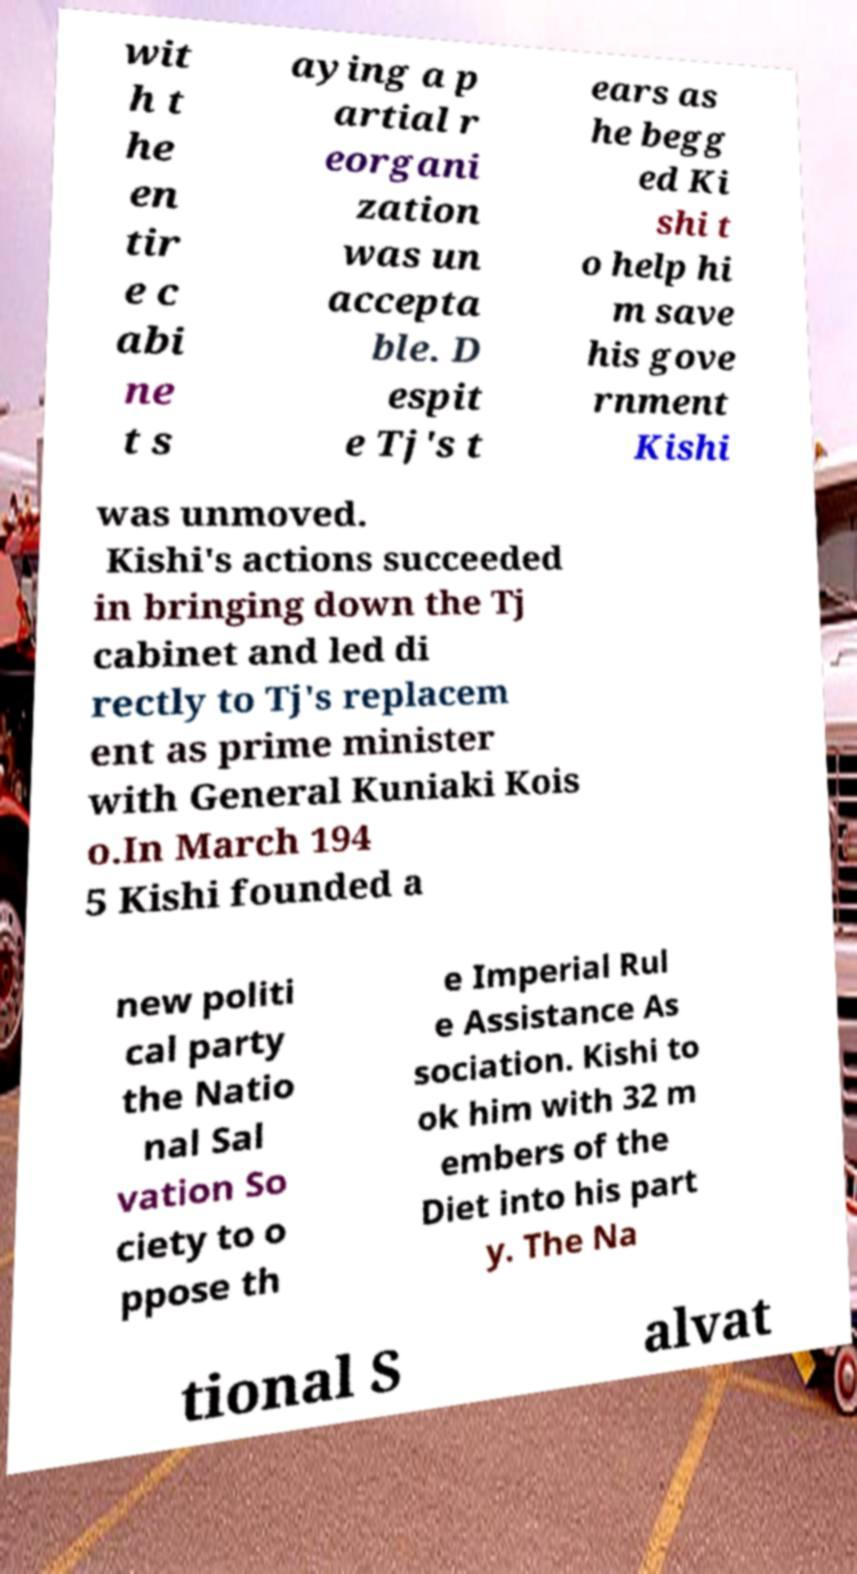Could you extract and type out the text from this image? wit h t he en tir e c abi ne t s aying a p artial r eorgani zation was un accepta ble. D espit e Tj's t ears as he begg ed Ki shi t o help hi m save his gove rnment Kishi was unmoved. Kishi's actions succeeded in bringing down the Tj cabinet and led di rectly to Tj's replacem ent as prime minister with General Kuniaki Kois o.In March 194 5 Kishi founded a new politi cal party the Natio nal Sal vation So ciety to o ppose th e Imperial Rul e Assistance As sociation. Kishi to ok him with 32 m embers of the Diet into his part y. The Na tional S alvat 